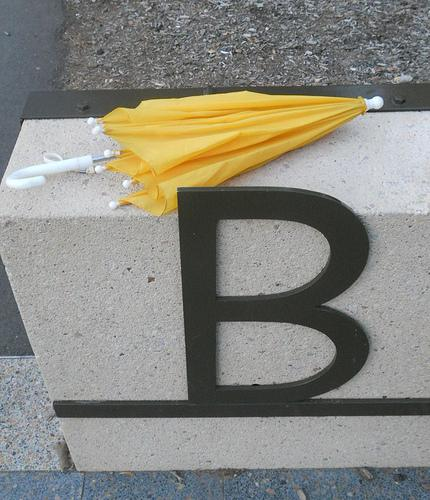Question: what color is behind the B?
Choices:
A. Brown.
B. Gray.
C. Blue.
D. Yellow.
Answer with the letter. Answer: B 